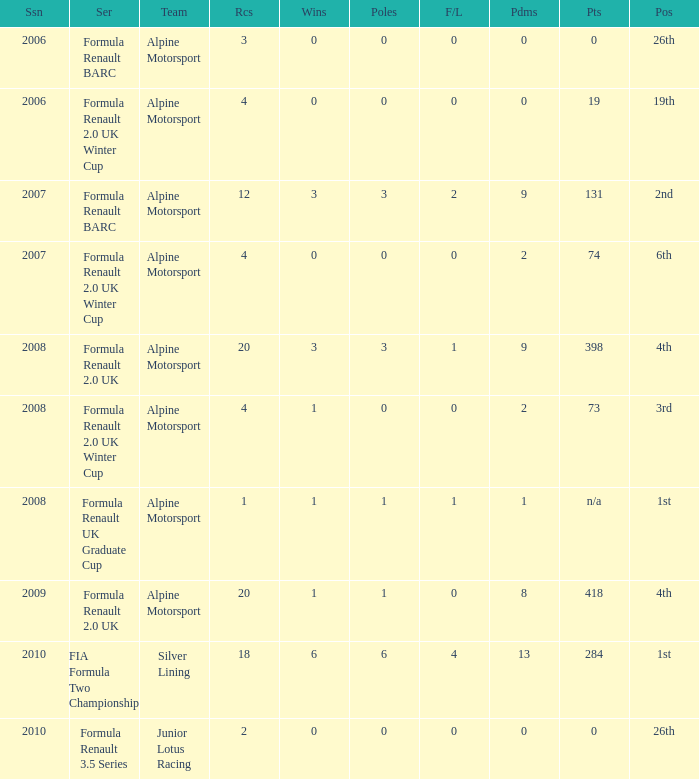What races achieved 0 f/laps and 1 pole position? 20.0. 